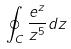<formula> <loc_0><loc_0><loc_500><loc_500>\oint _ { C } \frac { e ^ { z } } { z ^ { 5 } } d z</formula> 